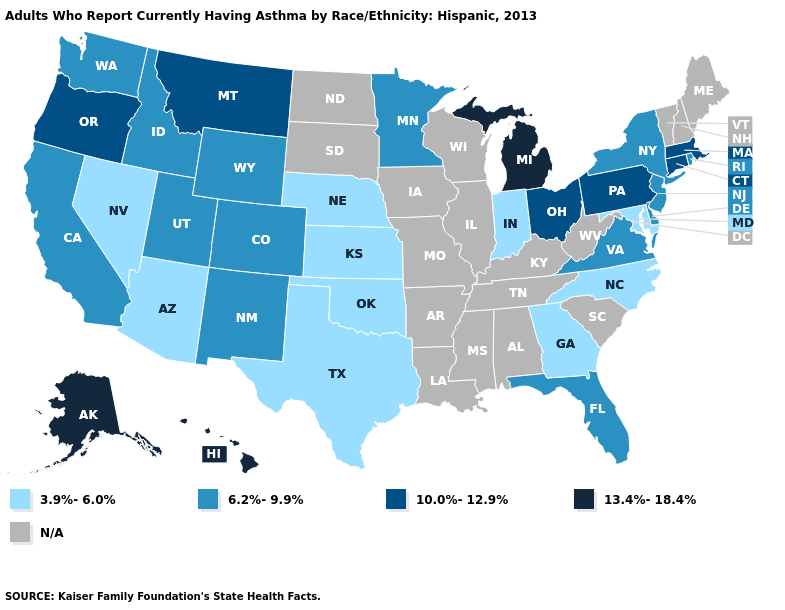Among the states that border Vermont , which have the highest value?
Give a very brief answer. Massachusetts. How many symbols are there in the legend?
Be succinct. 5. Name the states that have a value in the range 3.9%-6.0%?
Short answer required. Arizona, Georgia, Indiana, Kansas, Maryland, Nebraska, Nevada, North Carolina, Oklahoma, Texas. Does New Jersey have the highest value in the USA?
Quick response, please. No. What is the value of Washington?
Give a very brief answer. 6.2%-9.9%. Among the states that border Georgia , does Florida have the highest value?
Concise answer only. Yes. What is the lowest value in the West?
Concise answer only. 3.9%-6.0%. Does Connecticut have the lowest value in the USA?
Concise answer only. No. Which states have the lowest value in the MidWest?
Quick response, please. Indiana, Kansas, Nebraska. Name the states that have a value in the range 10.0%-12.9%?
Give a very brief answer. Connecticut, Massachusetts, Montana, Ohio, Oregon, Pennsylvania. What is the highest value in the MidWest ?
Write a very short answer. 13.4%-18.4%. What is the value of Colorado?
Keep it brief. 6.2%-9.9%. Does the map have missing data?
Keep it brief. Yes. What is the highest value in the USA?
Write a very short answer. 13.4%-18.4%. 